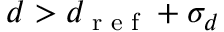<formula> <loc_0><loc_0><loc_500><loc_500>d > d _ { r e f } + \sigma _ { d }</formula> 